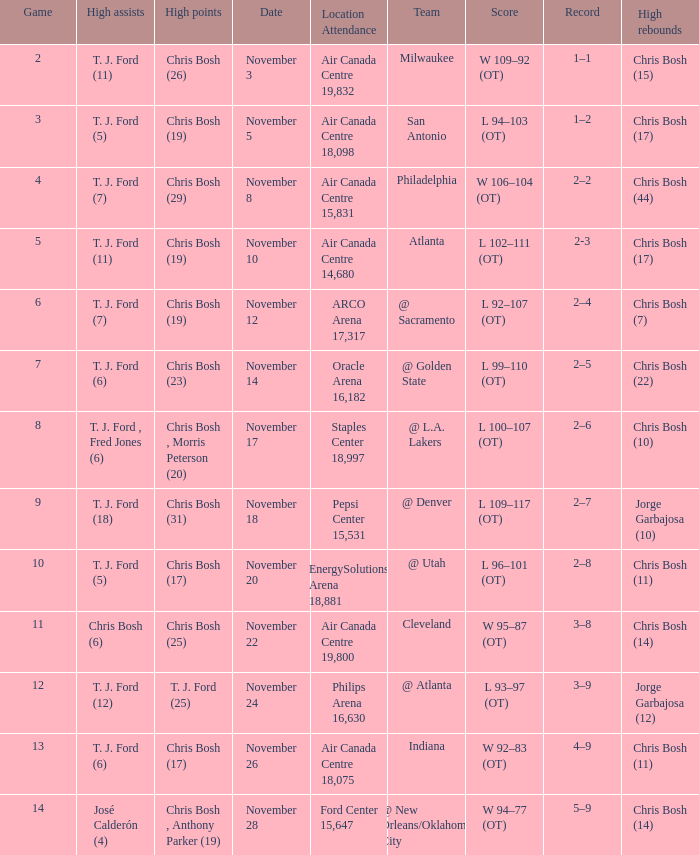Who scored the most points in game 4? Chris Bosh (29). 